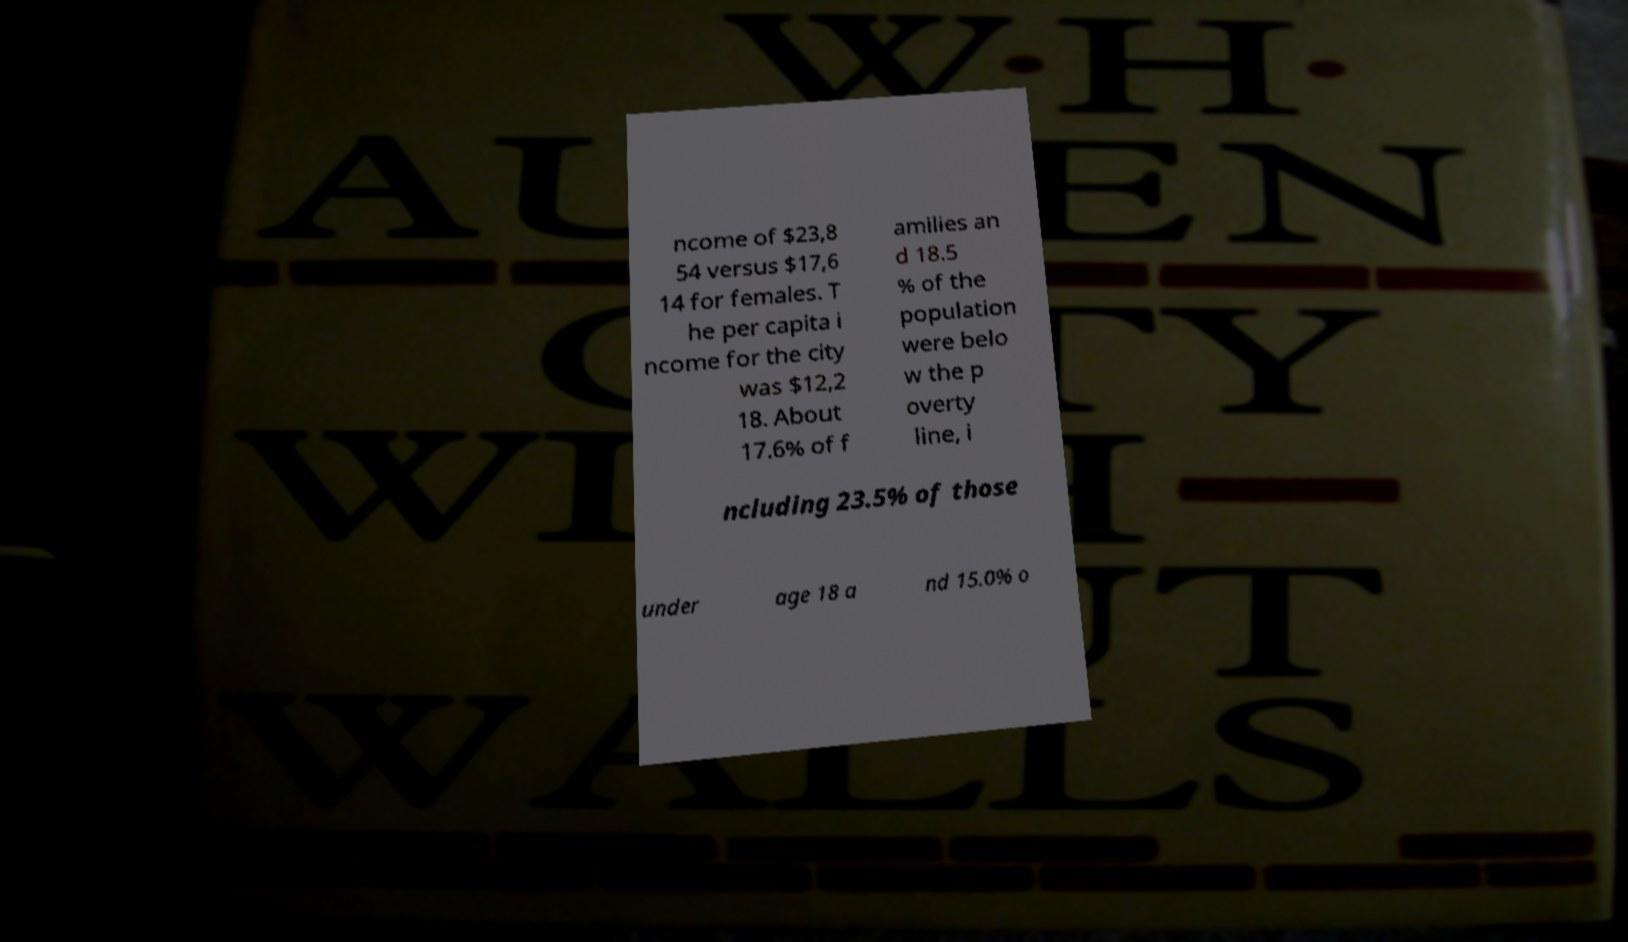There's text embedded in this image that I need extracted. Can you transcribe it verbatim? ncome of $23,8 54 versus $17,6 14 for females. T he per capita i ncome for the city was $12,2 18. About 17.6% of f amilies an d 18.5 % of the population were belo w the p overty line, i ncluding 23.5% of those under age 18 a nd 15.0% o 